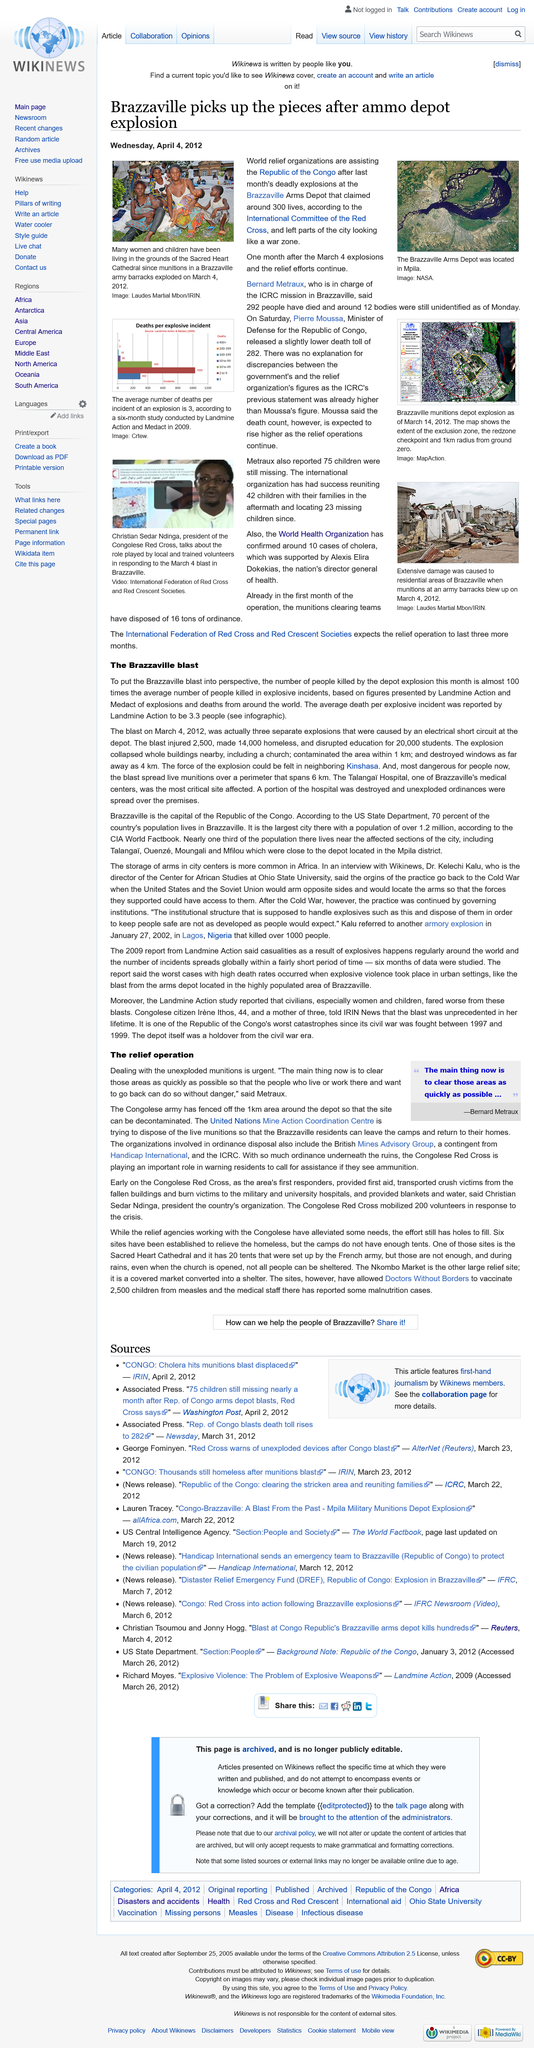Give some essential details in this illustration. Bernard Metraux stated that 292 people had died. The Brazzaville blast injured 2,500 people, made 14,000 homeless, and disrupted education for 20,000 students, resulting in the affected individuals facing significant hardships. On March 4, 2012, the Brazzaville blast occurred. The Brazzaville blast was caused by an electrical short circuit at the depot. The main thing to do during the relief operation, according to Bernard Metraux, is to clear the affected areas as quickly as possible. 